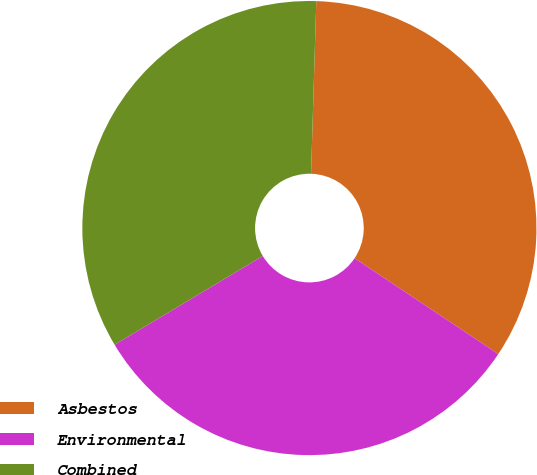Convert chart. <chart><loc_0><loc_0><loc_500><loc_500><pie_chart><fcel>Asbestos<fcel>Environmental<fcel>Combined<nl><fcel>33.88%<fcel>32.05%<fcel>34.07%<nl></chart> 